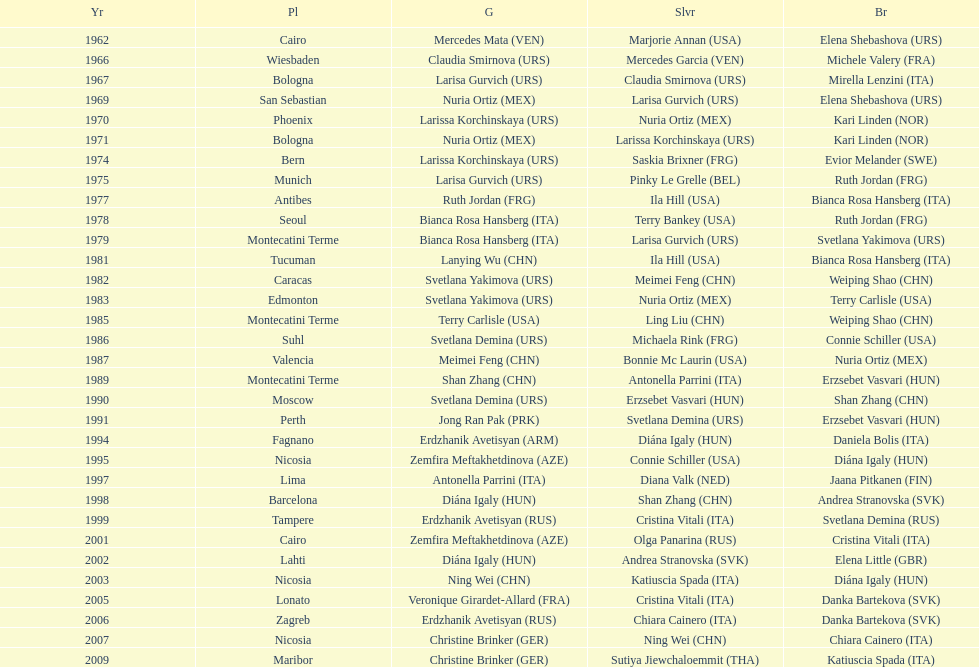Which country has won more gold medals: china or mexico? China. 